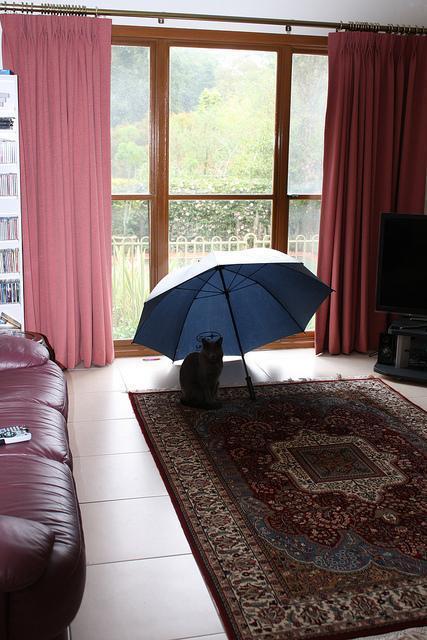How many people on the court are in orange?
Give a very brief answer. 0. 